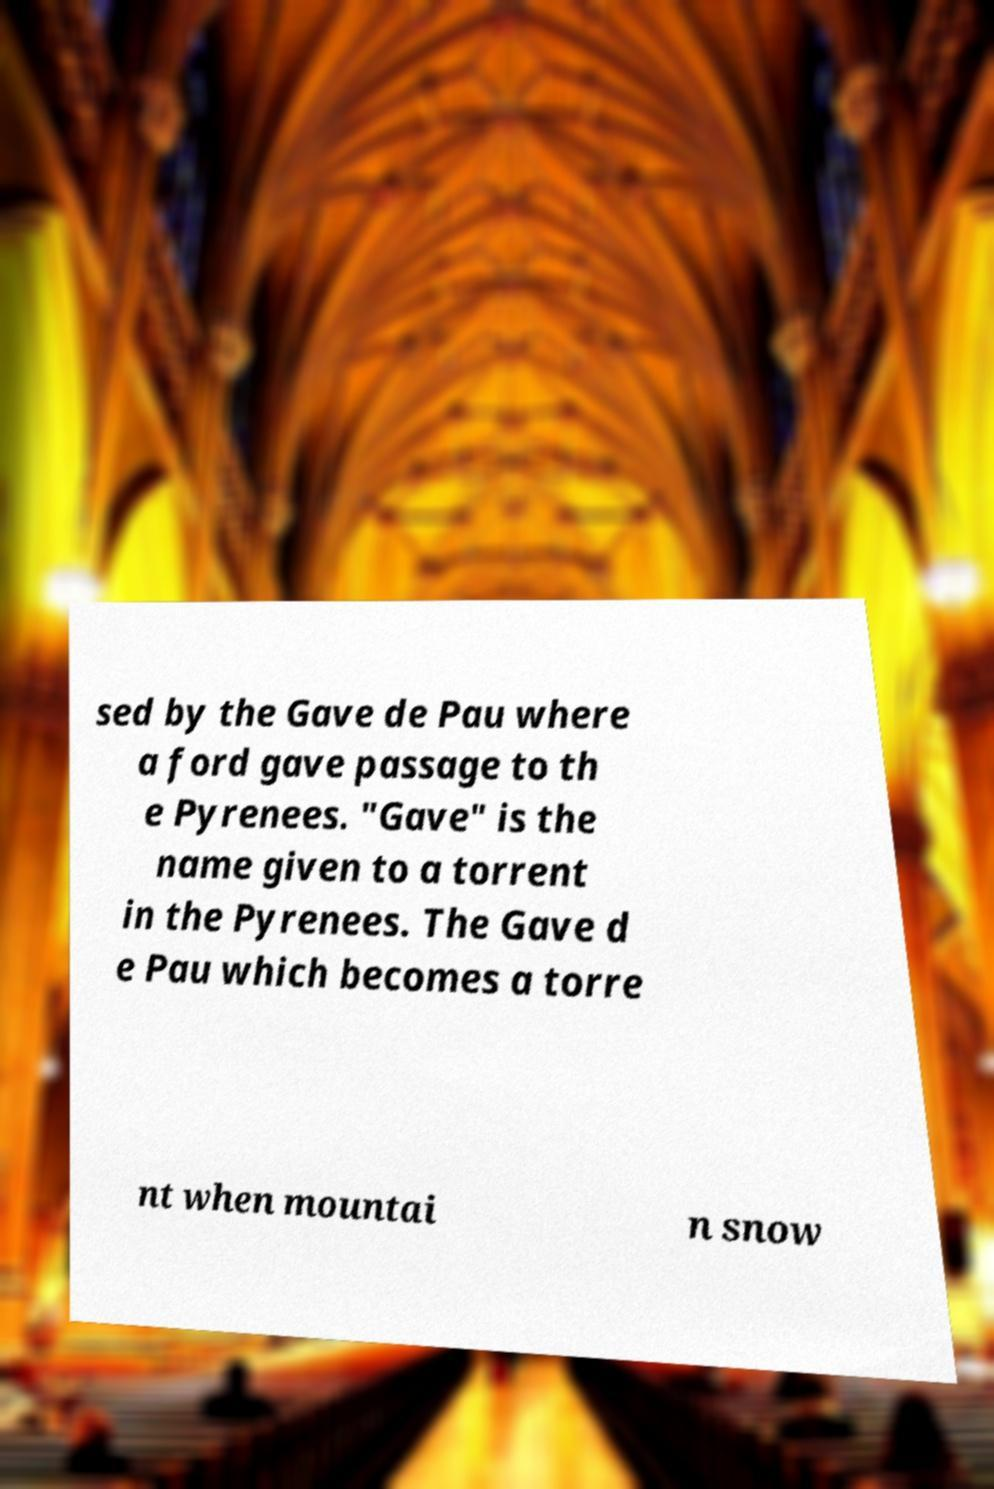I need the written content from this picture converted into text. Can you do that? sed by the Gave de Pau where a ford gave passage to th e Pyrenees. "Gave" is the name given to a torrent in the Pyrenees. The Gave d e Pau which becomes a torre nt when mountai n snow 